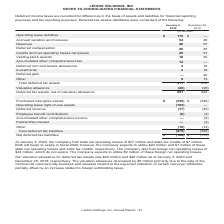According to Leidos Holdings's financial document, What were the state net operating losses in 2020? According to the financial document, $77 million. The relevant text states: "020, the Company had state net operating losses of $77 million and state tax credits of $7 million. Both will begin to expire in fiscal 2020; however, the Company..." Also, What was the valuation allowance for deferred tax assets in 2020 and 2018 respectively? The document shows two values: $20 million and $28 million. From the document: "ur valuation allowance for deferred tax assets was $20 million and $28 million as of January 3, 2020 and December 28, 2018, respectively. The valuatio..." Also, What was the Operating lease liabilities in 2020? According to the financial document, $115 (in millions). The relevant text states: "(in millions) Operating lease liabilities $ 115 $ — Accrued vacation and bonuses 54 48 Reserves 46 57 Deferred compensation 26 25 Credits and net o..." Additionally, In which period was Operating lease liabilities less than 100 million? According to the financial document, 2018. The relevant text states: "January 3, 2020 December 28, 2018..." Also, can you calculate: What is the change in the Accrued vacation and bonuses from 2018 to 2020? Based on the calculation: 54 - 48, the result is 6 (in millions). This is based on the information: "iabilities $ 115 $ — Accrued vacation and bonuses 54 48 Reserves 46 57 Deferred compensation 26 25 Credits and net operating losses carryovers 25 31 Ves ilities $ 115 $ — Accrued vacation and bonuses ..." The key data points involved are: 48, 54. Also, can you calculate: What is the change in the Reserves from 2018 to 2020? Based on the calculation: 46 - 57, the result is -11 (in millions). This is based on the information: "— Accrued vacation and bonuses 54 48 Reserves 46 57 Deferred compensation 26 25 Credits and net operating losses carryovers 25 31 Vesting stock awards 5 $ — Accrued vacation and bonuses 54 48 Reserves..." The key data points involved are: 46, 57. 